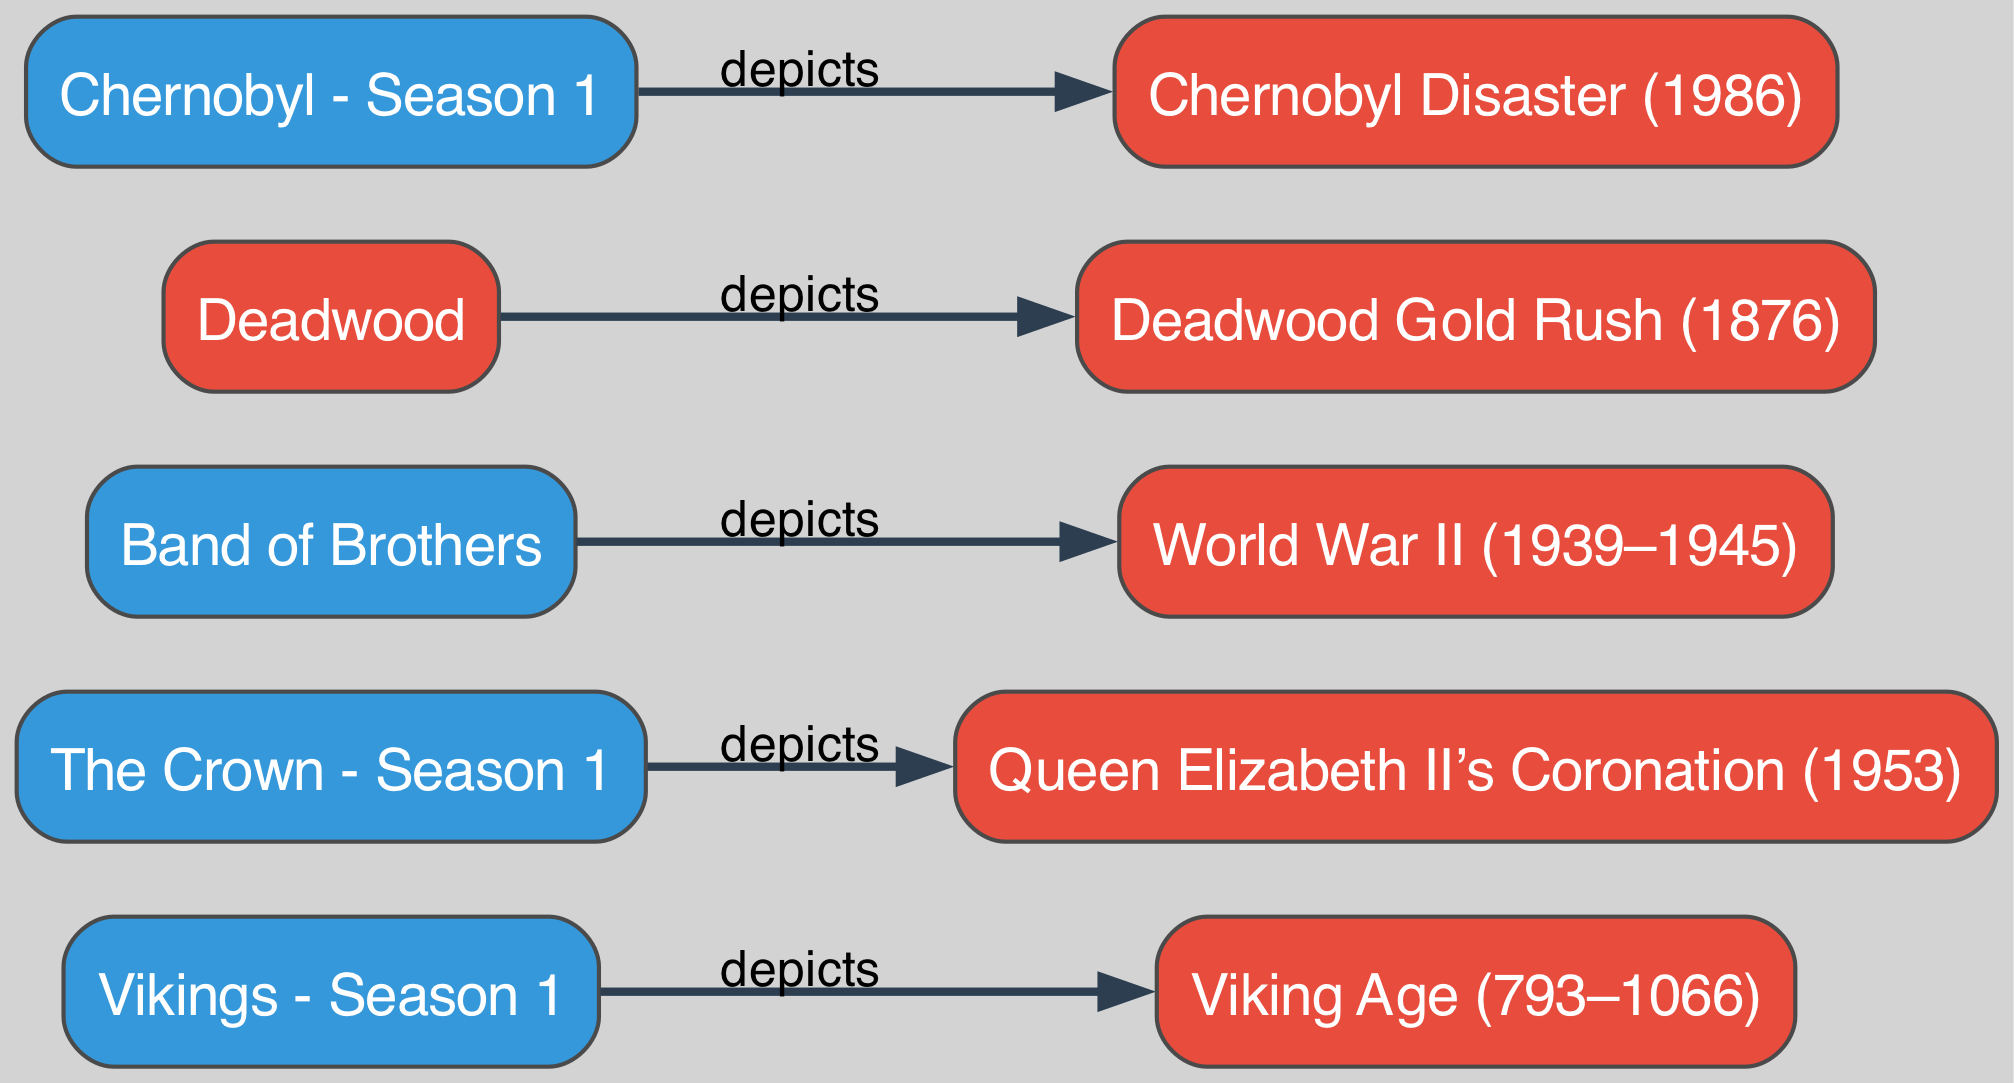What is the total number of nodes in the diagram? The diagram features a total of 10 nodes, which include both TV shows and historical events. I counted each unique entry by reviewing the list of nodes provided.
Answer: 10 Which historical event is depicted in "Chernobyl - Season 1"? The diagram indicates that "Chernobyl - Season 1" depicts the "Chernobyl Disaster (1986)" by following the link from node I to node J.
Answer: Chernobyl Disaster (1986) Which television show is related to the Viking Age? The link between "Vikings - Season 1" and "Viking Age (793–1066)" reveals that this show portrays events from that historical period, connecting node A to node B.
Answer: Vikings - Season 1 How many links connect to historical events? The diagram shows a total of 5 links, each connecting a TV show to a corresponding historical event, which I established by counting the links listed in the data.
Answer: 5 What year does "Queen Elizabeth II’s Coronation" occur according to the diagram? The diagram clearly states that "Queen Elizabeth II's Coronation" took place in "1953," as indicated by node D being linked to node C.
Answer: 1953 How many links are there between television shows and historical events involving wars? There are 2 links connecting television shows to wars: "Band of Brothers" to "World War II (1939–1945)" and "Deadwood" to "Deadwood Gold Rush (1876)".
Answer: 2 Which television show has the oldest historical association based on the diagram? Based on the timeline illustrated in the diagram, "Vikings - Season 1" associates with the Viking Age (793–1066), making it the earliest historical connection.
Answer: Vikings - Season 1 Which node is an illustration of a disaster? The node "Chernobyl - Season 1" is specifically related to the illustrated disaster, as it links to "Chernobyl Disaster (1986)" through the diagram, confirming its identity as a disaster.
Answer: Chernobyl - Season 1 What color represents the television shows in the diagram? The color blue represents the television shows, as can be seen from the color attribute defined for the nodes categorized as TV shows.
Answer: Blue 